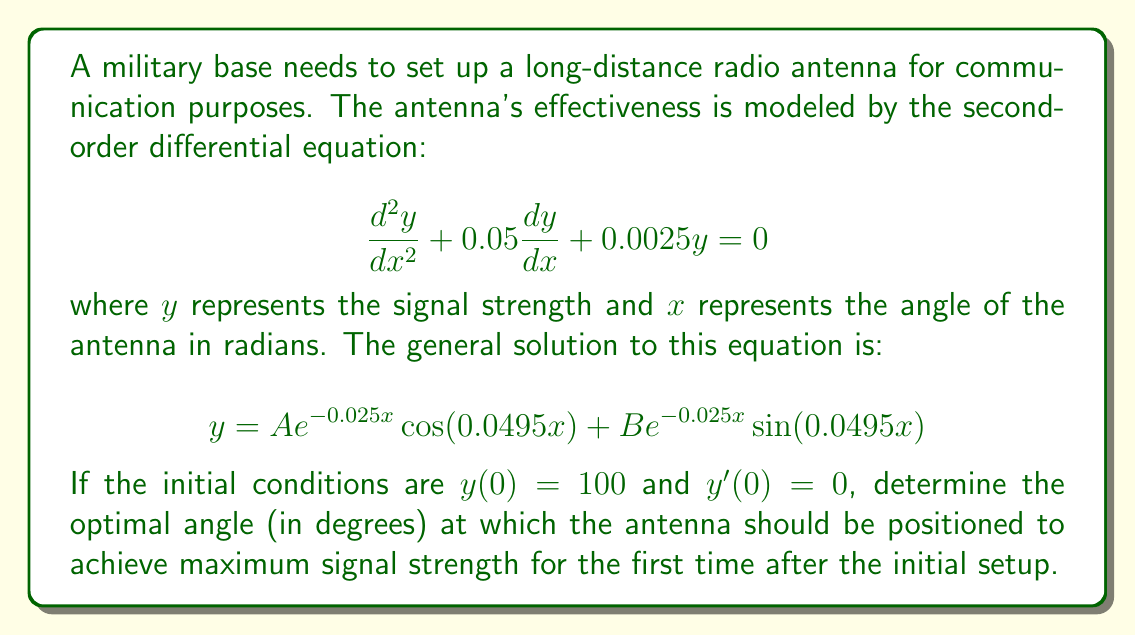Provide a solution to this math problem. Let's approach this step-by-step:

1) First, we need to find the values of A and B using the initial conditions:

   At $x = 0$, $y(0) = 100$:
   $100 = A \cdot 1 + B \cdot 0$, so $A = 100$

   For $y'(0) = 0$:
   $y' = -2.5A e^{-0.025x} \cos(0.0495x) + 4.95A e^{-0.025x} \sin(0.0495x) - 2.5B e^{-0.025x} \sin(0.0495x) + 4.95B e^{-0.025x} \cos(0.0495x)$
   
   At $x = 0$: $0 = -2.5A + 4.95B$
   $0 = -2.5(100) + 4.95B$
   $B = 50.51$

2) So our specific solution is:
   $$y = 100 e^{-0.025x} \cos(0.0495x) + 50.51 e^{-0.025x} \sin(0.0495x)$$

3) To find the maximum, we need to find where $\frac{dy}{dx} = 0$:
   $$\frac{dy}{dx} = -2.5e^{-0.025x}(100\cos(0.0495x) + 50.51\sin(0.0495x)) + e^{-0.025x}(-4.95(100\sin(0.0495x)) + 4.95(50.51\cos(0.0495x)))$$

4) Setting this equal to zero and simplifying:
   $$\tan(0.0495x) = \frac{247.5}{126.275} \approx 1.96$$

5) Solving for x:
   $$x = \frac{1}{0.0495} \arctan(1.96) \approx 38.1$$

6) Converting to degrees:
   $38.1 \text{ radians} \times \frac{180^\circ}{\pi} \approx 2183.6^\circ$

7) Since we're looking for the first maximum after the initial setup, we need to subtract $360^\circ$ until we get an angle less than $360^\circ$:
   $2183.6^\circ - 6(360^\circ) = 23.6^\circ$
Answer: The optimal angle for the antenna is approximately $23.6^\circ$. 